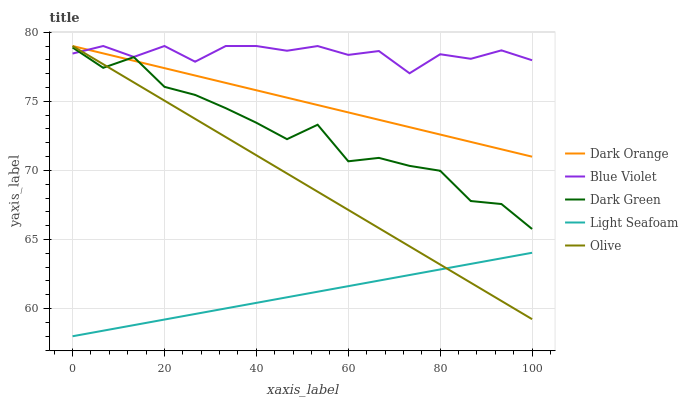Does Light Seafoam have the minimum area under the curve?
Answer yes or no. Yes. Does Blue Violet have the maximum area under the curve?
Answer yes or no. Yes. Does Dark Orange have the minimum area under the curve?
Answer yes or no. No. Does Dark Orange have the maximum area under the curve?
Answer yes or no. No. Is Light Seafoam the smoothest?
Answer yes or no. Yes. Is Dark Green the roughest?
Answer yes or no. Yes. Is Dark Orange the smoothest?
Answer yes or no. No. Is Dark Orange the roughest?
Answer yes or no. No. Does Light Seafoam have the lowest value?
Answer yes or no. Yes. Does Dark Orange have the lowest value?
Answer yes or no. No. Does Blue Violet have the highest value?
Answer yes or no. Yes. Does Light Seafoam have the highest value?
Answer yes or no. No. Is Light Seafoam less than Blue Violet?
Answer yes or no. Yes. Is Dark Green greater than Light Seafoam?
Answer yes or no. Yes. Does Dark Green intersect Dark Orange?
Answer yes or no. Yes. Is Dark Green less than Dark Orange?
Answer yes or no. No. Is Dark Green greater than Dark Orange?
Answer yes or no. No. Does Light Seafoam intersect Blue Violet?
Answer yes or no. No. 